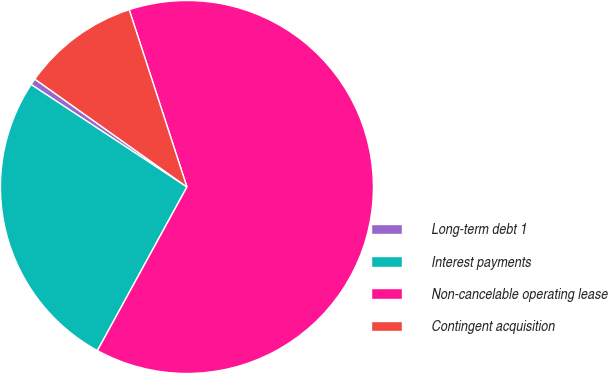Convert chart. <chart><loc_0><loc_0><loc_500><loc_500><pie_chart><fcel>Long-term debt 1<fcel>Interest payments<fcel>Non-cancelable operating lease<fcel>Contingent acquisition<nl><fcel>0.56%<fcel>26.29%<fcel>62.98%<fcel>10.17%<nl></chart> 